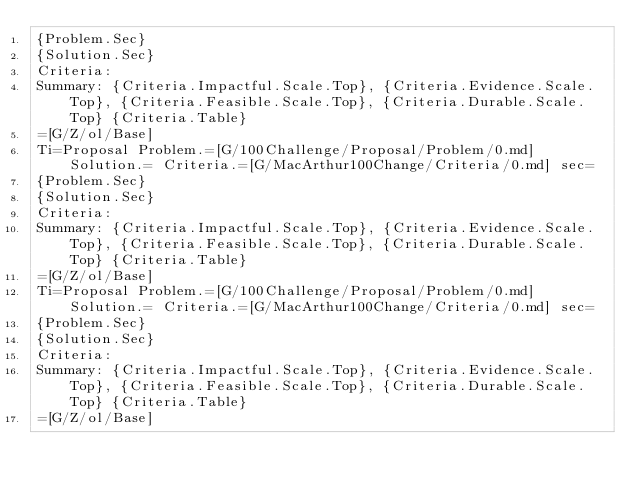<code> <loc_0><loc_0><loc_500><loc_500><_HTML_>{Problem.Sec}
{Solution.Sec}
Criteria:
Summary: {Criteria.Impactful.Scale.Top}, {Criteria.Evidence.Scale.Top}, {Criteria.Feasible.Scale.Top}, {Criteria.Durable.Scale.Top} {Criteria.Table}
=[G/Z/ol/Base]
Ti=Proposal Problem.=[G/100Challenge/Proposal/Problem/0.md] Solution.= Criteria.=[G/MacArthur100Change/Criteria/0.md] sec=
{Problem.Sec}
{Solution.Sec}
Criteria:
Summary: {Criteria.Impactful.Scale.Top}, {Criteria.Evidence.Scale.Top}, {Criteria.Feasible.Scale.Top}, {Criteria.Durable.Scale.Top} {Criteria.Table}
=[G/Z/ol/Base]
Ti=Proposal Problem.=[G/100Challenge/Proposal/Problem/0.md] Solution.= Criteria.=[G/MacArthur100Change/Criteria/0.md] sec=
{Problem.Sec}
{Solution.Sec}
Criteria:
Summary: {Criteria.Impactful.Scale.Top}, {Criteria.Evidence.Scale.Top}, {Criteria.Feasible.Scale.Top}, {Criteria.Durable.Scale.Top} {Criteria.Table}
=[G/Z/ol/Base]</code> 